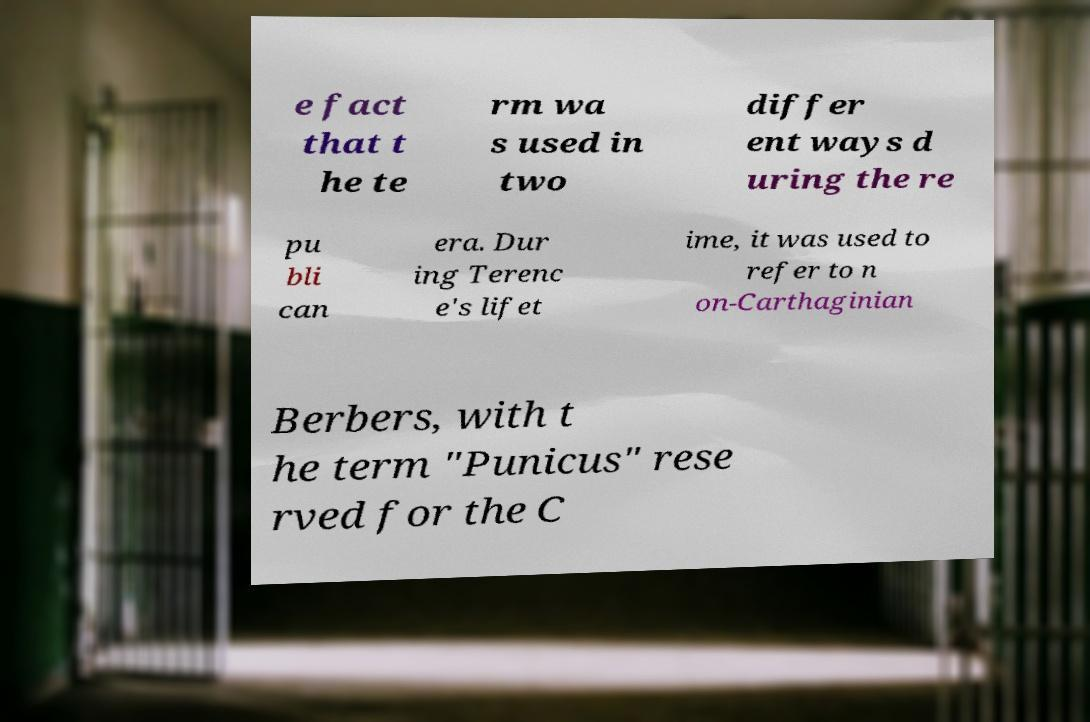Can you read and provide the text displayed in the image?This photo seems to have some interesting text. Can you extract and type it out for me? e fact that t he te rm wa s used in two differ ent ways d uring the re pu bli can era. Dur ing Terenc e's lifet ime, it was used to refer to n on-Carthaginian Berbers, with t he term "Punicus" rese rved for the C 